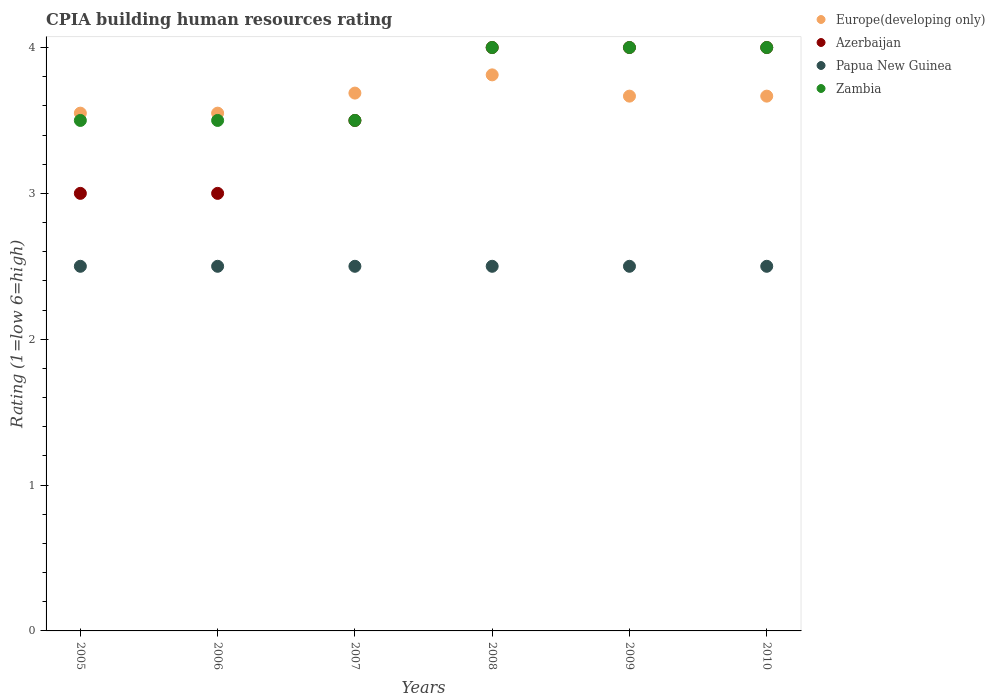How many different coloured dotlines are there?
Offer a terse response. 4. Is the number of dotlines equal to the number of legend labels?
Provide a short and direct response. Yes. What is the CPIA rating in Europe(developing only) in 2006?
Your response must be concise. 3.55. Across all years, what is the maximum CPIA rating in Europe(developing only)?
Your answer should be very brief. 3.81. Across all years, what is the minimum CPIA rating in Europe(developing only)?
Give a very brief answer. 3.55. What is the total CPIA rating in Papua New Guinea in the graph?
Your response must be concise. 15. What is the difference between the CPIA rating in Europe(developing only) in 2008 and that in 2009?
Your answer should be compact. 0.15. What is the average CPIA rating in Europe(developing only) per year?
Ensure brevity in your answer.  3.66. In the year 2009, what is the difference between the CPIA rating in Azerbaijan and CPIA rating in Europe(developing only)?
Make the answer very short. 0.33. In how many years, is the CPIA rating in Zambia greater than 3.2?
Ensure brevity in your answer.  6. What is the ratio of the CPIA rating in Europe(developing only) in 2006 to that in 2010?
Keep it short and to the point. 0.97. Is the CPIA rating in Zambia in 2007 less than that in 2010?
Provide a short and direct response. Yes. Is the difference between the CPIA rating in Azerbaijan in 2007 and 2008 greater than the difference between the CPIA rating in Europe(developing only) in 2007 and 2008?
Your answer should be compact. No. What is the difference between the highest and the second highest CPIA rating in Europe(developing only)?
Provide a succinct answer. 0.12. What is the difference between the highest and the lowest CPIA rating in Europe(developing only)?
Your answer should be very brief. 0.26. Is it the case that in every year, the sum of the CPIA rating in Zambia and CPIA rating in Europe(developing only)  is greater than the CPIA rating in Papua New Guinea?
Your answer should be compact. Yes. Is the CPIA rating in Europe(developing only) strictly less than the CPIA rating in Zambia over the years?
Your response must be concise. No. How many years are there in the graph?
Provide a short and direct response. 6. Does the graph contain any zero values?
Your answer should be very brief. No. Where does the legend appear in the graph?
Give a very brief answer. Top right. How many legend labels are there?
Provide a succinct answer. 4. How are the legend labels stacked?
Provide a short and direct response. Vertical. What is the title of the graph?
Offer a very short reply. CPIA building human resources rating. Does "Argentina" appear as one of the legend labels in the graph?
Ensure brevity in your answer.  No. What is the label or title of the X-axis?
Offer a terse response. Years. What is the Rating (1=low 6=high) in Europe(developing only) in 2005?
Your response must be concise. 3.55. What is the Rating (1=low 6=high) of Europe(developing only) in 2006?
Offer a very short reply. 3.55. What is the Rating (1=low 6=high) of Azerbaijan in 2006?
Provide a short and direct response. 3. What is the Rating (1=low 6=high) in Zambia in 2006?
Your answer should be compact. 3.5. What is the Rating (1=low 6=high) of Europe(developing only) in 2007?
Your answer should be compact. 3.69. What is the Rating (1=low 6=high) of Azerbaijan in 2007?
Offer a terse response. 3.5. What is the Rating (1=low 6=high) of Papua New Guinea in 2007?
Your answer should be compact. 2.5. What is the Rating (1=low 6=high) of Europe(developing only) in 2008?
Offer a very short reply. 3.81. What is the Rating (1=low 6=high) in Azerbaijan in 2008?
Offer a very short reply. 4. What is the Rating (1=low 6=high) of Zambia in 2008?
Offer a terse response. 4. What is the Rating (1=low 6=high) in Europe(developing only) in 2009?
Give a very brief answer. 3.67. What is the Rating (1=low 6=high) in Azerbaijan in 2009?
Make the answer very short. 4. What is the Rating (1=low 6=high) in Papua New Guinea in 2009?
Give a very brief answer. 2.5. What is the Rating (1=low 6=high) in Zambia in 2009?
Provide a short and direct response. 4. What is the Rating (1=low 6=high) of Europe(developing only) in 2010?
Your answer should be very brief. 3.67. What is the Rating (1=low 6=high) of Azerbaijan in 2010?
Make the answer very short. 4. Across all years, what is the maximum Rating (1=low 6=high) in Europe(developing only)?
Keep it short and to the point. 3.81. Across all years, what is the maximum Rating (1=low 6=high) in Azerbaijan?
Give a very brief answer. 4. Across all years, what is the maximum Rating (1=low 6=high) in Papua New Guinea?
Provide a short and direct response. 2.5. Across all years, what is the minimum Rating (1=low 6=high) of Europe(developing only)?
Offer a very short reply. 3.55. Across all years, what is the minimum Rating (1=low 6=high) in Azerbaijan?
Make the answer very short. 3. Across all years, what is the minimum Rating (1=low 6=high) in Zambia?
Your answer should be compact. 3.5. What is the total Rating (1=low 6=high) of Europe(developing only) in the graph?
Your response must be concise. 21.93. What is the total Rating (1=low 6=high) in Azerbaijan in the graph?
Provide a succinct answer. 21.5. What is the total Rating (1=low 6=high) of Papua New Guinea in the graph?
Give a very brief answer. 15. What is the difference between the Rating (1=low 6=high) in Papua New Guinea in 2005 and that in 2006?
Offer a terse response. 0. What is the difference between the Rating (1=low 6=high) in Zambia in 2005 and that in 2006?
Your response must be concise. 0. What is the difference between the Rating (1=low 6=high) of Europe(developing only) in 2005 and that in 2007?
Offer a very short reply. -0.14. What is the difference between the Rating (1=low 6=high) in Azerbaijan in 2005 and that in 2007?
Your answer should be very brief. -0.5. What is the difference between the Rating (1=low 6=high) of Papua New Guinea in 2005 and that in 2007?
Your answer should be very brief. 0. What is the difference between the Rating (1=low 6=high) in Zambia in 2005 and that in 2007?
Offer a very short reply. 0. What is the difference between the Rating (1=low 6=high) of Europe(developing only) in 2005 and that in 2008?
Your response must be concise. -0.26. What is the difference between the Rating (1=low 6=high) in Azerbaijan in 2005 and that in 2008?
Your answer should be very brief. -1. What is the difference between the Rating (1=low 6=high) of Papua New Guinea in 2005 and that in 2008?
Offer a very short reply. 0. What is the difference between the Rating (1=low 6=high) of Europe(developing only) in 2005 and that in 2009?
Make the answer very short. -0.12. What is the difference between the Rating (1=low 6=high) in Azerbaijan in 2005 and that in 2009?
Keep it short and to the point. -1. What is the difference between the Rating (1=low 6=high) of Papua New Guinea in 2005 and that in 2009?
Give a very brief answer. 0. What is the difference between the Rating (1=low 6=high) of Zambia in 2005 and that in 2009?
Your answer should be very brief. -0.5. What is the difference between the Rating (1=low 6=high) in Europe(developing only) in 2005 and that in 2010?
Provide a succinct answer. -0.12. What is the difference between the Rating (1=low 6=high) of Papua New Guinea in 2005 and that in 2010?
Offer a terse response. 0. What is the difference between the Rating (1=low 6=high) in Zambia in 2005 and that in 2010?
Your answer should be very brief. -0.5. What is the difference between the Rating (1=low 6=high) in Europe(developing only) in 2006 and that in 2007?
Your answer should be compact. -0.14. What is the difference between the Rating (1=low 6=high) in Europe(developing only) in 2006 and that in 2008?
Ensure brevity in your answer.  -0.26. What is the difference between the Rating (1=low 6=high) in Papua New Guinea in 2006 and that in 2008?
Your answer should be compact. 0. What is the difference between the Rating (1=low 6=high) of Europe(developing only) in 2006 and that in 2009?
Keep it short and to the point. -0.12. What is the difference between the Rating (1=low 6=high) of Azerbaijan in 2006 and that in 2009?
Provide a short and direct response. -1. What is the difference between the Rating (1=low 6=high) of Papua New Guinea in 2006 and that in 2009?
Your response must be concise. 0. What is the difference between the Rating (1=low 6=high) of Zambia in 2006 and that in 2009?
Your answer should be very brief. -0.5. What is the difference between the Rating (1=low 6=high) in Europe(developing only) in 2006 and that in 2010?
Make the answer very short. -0.12. What is the difference between the Rating (1=low 6=high) of Azerbaijan in 2006 and that in 2010?
Make the answer very short. -1. What is the difference between the Rating (1=low 6=high) of Papua New Guinea in 2006 and that in 2010?
Provide a succinct answer. 0. What is the difference between the Rating (1=low 6=high) in Zambia in 2006 and that in 2010?
Offer a very short reply. -0.5. What is the difference between the Rating (1=low 6=high) of Europe(developing only) in 2007 and that in 2008?
Provide a succinct answer. -0.12. What is the difference between the Rating (1=low 6=high) in Papua New Guinea in 2007 and that in 2008?
Give a very brief answer. 0. What is the difference between the Rating (1=low 6=high) in Europe(developing only) in 2007 and that in 2009?
Ensure brevity in your answer.  0.02. What is the difference between the Rating (1=low 6=high) in Papua New Guinea in 2007 and that in 2009?
Keep it short and to the point. 0. What is the difference between the Rating (1=low 6=high) of Europe(developing only) in 2007 and that in 2010?
Make the answer very short. 0.02. What is the difference between the Rating (1=low 6=high) of Azerbaijan in 2007 and that in 2010?
Your response must be concise. -0.5. What is the difference between the Rating (1=low 6=high) of Zambia in 2007 and that in 2010?
Make the answer very short. -0.5. What is the difference between the Rating (1=low 6=high) of Europe(developing only) in 2008 and that in 2009?
Offer a terse response. 0.15. What is the difference between the Rating (1=low 6=high) in Papua New Guinea in 2008 and that in 2009?
Keep it short and to the point. 0. What is the difference between the Rating (1=low 6=high) of Zambia in 2008 and that in 2009?
Offer a very short reply. 0. What is the difference between the Rating (1=low 6=high) of Europe(developing only) in 2008 and that in 2010?
Keep it short and to the point. 0.15. What is the difference between the Rating (1=low 6=high) of Zambia in 2008 and that in 2010?
Make the answer very short. 0. What is the difference between the Rating (1=low 6=high) in Europe(developing only) in 2009 and that in 2010?
Your answer should be compact. 0. What is the difference between the Rating (1=low 6=high) in Azerbaijan in 2009 and that in 2010?
Offer a terse response. 0. What is the difference between the Rating (1=low 6=high) in Europe(developing only) in 2005 and the Rating (1=low 6=high) in Azerbaijan in 2006?
Your response must be concise. 0.55. What is the difference between the Rating (1=low 6=high) in Europe(developing only) in 2005 and the Rating (1=low 6=high) in Papua New Guinea in 2006?
Provide a short and direct response. 1.05. What is the difference between the Rating (1=low 6=high) of Europe(developing only) in 2005 and the Rating (1=low 6=high) of Zambia in 2006?
Your answer should be very brief. 0.05. What is the difference between the Rating (1=low 6=high) of Azerbaijan in 2005 and the Rating (1=low 6=high) of Zambia in 2006?
Give a very brief answer. -0.5. What is the difference between the Rating (1=low 6=high) in Europe(developing only) in 2005 and the Rating (1=low 6=high) in Azerbaijan in 2007?
Offer a very short reply. 0.05. What is the difference between the Rating (1=low 6=high) in Europe(developing only) in 2005 and the Rating (1=low 6=high) in Papua New Guinea in 2007?
Your answer should be compact. 1.05. What is the difference between the Rating (1=low 6=high) in Azerbaijan in 2005 and the Rating (1=low 6=high) in Zambia in 2007?
Your answer should be compact. -0.5. What is the difference between the Rating (1=low 6=high) in Europe(developing only) in 2005 and the Rating (1=low 6=high) in Azerbaijan in 2008?
Keep it short and to the point. -0.45. What is the difference between the Rating (1=low 6=high) of Europe(developing only) in 2005 and the Rating (1=low 6=high) of Papua New Guinea in 2008?
Provide a succinct answer. 1.05. What is the difference between the Rating (1=low 6=high) of Europe(developing only) in 2005 and the Rating (1=low 6=high) of Zambia in 2008?
Give a very brief answer. -0.45. What is the difference between the Rating (1=low 6=high) of Azerbaijan in 2005 and the Rating (1=low 6=high) of Zambia in 2008?
Give a very brief answer. -1. What is the difference between the Rating (1=low 6=high) in Europe(developing only) in 2005 and the Rating (1=low 6=high) in Azerbaijan in 2009?
Offer a terse response. -0.45. What is the difference between the Rating (1=low 6=high) in Europe(developing only) in 2005 and the Rating (1=low 6=high) in Papua New Guinea in 2009?
Offer a terse response. 1.05. What is the difference between the Rating (1=low 6=high) of Europe(developing only) in 2005 and the Rating (1=low 6=high) of Zambia in 2009?
Provide a short and direct response. -0.45. What is the difference between the Rating (1=low 6=high) in Azerbaijan in 2005 and the Rating (1=low 6=high) in Zambia in 2009?
Keep it short and to the point. -1. What is the difference between the Rating (1=low 6=high) in Europe(developing only) in 2005 and the Rating (1=low 6=high) in Azerbaijan in 2010?
Offer a terse response. -0.45. What is the difference between the Rating (1=low 6=high) of Europe(developing only) in 2005 and the Rating (1=low 6=high) of Papua New Guinea in 2010?
Give a very brief answer. 1.05. What is the difference between the Rating (1=low 6=high) in Europe(developing only) in 2005 and the Rating (1=low 6=high) in Zambia in 2010?
Your answer should be very brief. -0.45. What is the difference between the Rating (1=low 6=high) in Azerbaijan in 2005 and the Rating (1=low 6=high) in Papua New Guinea in 2010?
Ensure brevity in your answer.  0.5. What is the difference between the Rating (1=low 6=high) in Azerbaijan in 2005 and the Rating (1=low 6=high) in Zambia in 2010?
Offer a very short reply. -1. What is the difference between the Rating (1=low 6=high) of Europe(developing only) in 2006 and the Rating (1=low 6=high) of Papua New Guinea in 2007?
Your answer should be very brief. 1.05. What is the difference between the Rating (1=low 6=high) in Europe(developing only) in 2006 and the Rating (1=low 6=high) in Zambia in 2007?
Offer a very short reply. 0.05. What is the difference between the Rating (1=low 6=high) in Azerbaijan in 2006 and the Rating (1=low 6=high) in Zambia in 2007?
Offer a terse response. -0.5. What is the difference between the Rating (1=low 6=high) in Papua New Guinea in 2006 and the Rating (1=low 6=high) in Zambia in 2007?
Keep it short and to the point. -1. What is the difference between the Rating (1=low 6=high) in Europe(developing only) in 2006 and the Rating (1=low 6=high) in Azerbaijan in 2008?
Your answer should be compact. -0.45. What is the difference between the Rating (1=low 6=high) in Europe(developing only) in 2006 and the Rating (1=low 6=high) in Papua New Guinea in 2008?
Your answer should be very brief. 1.05. What is the difference between the Rating (1=low 6=high) of Europe(developing only) in 2006 and the Rating (1=low 6=high) of Zambia in 2008?
Make the answer very short. -0.45. What is the difference between the Rating (1=low 6=high) in Azerbaijan in 2006 and the Rating (1=low 6=high) in Papua New Guinea in 2008?
Your response must be concise. 0.5. What is the difference between the Rating (1=low 6=high) in Azerbaijan in 2006 and the Rating (1=low 6=high) in Zambia in 2008?
Your response must be concise. -1. What is the difference between the Rating (1=low 6=high) of Europe(developing only) in 2006 and the Rating (1=low 6=high) of Azerbaijan in 2009?
Offer a very short reply. -0.45. What is the difference between the Rating (1=low 6=high) in Europe(developing only) in 2006 and the Rating (1=low 6=high) in Zambia in 2009?
Your response must be concise. -0.45. What is the difference between the Rating (1=low 6=high) of Azerbaijan in 2006 and the Rating (1=low 6=high) of Papua New Guinea in 2009?
Your answer should be compact. 0.5. What is the difference between the Rating (1=low 6=high) of Azerbaijan in 2006 and the Rating (1=low 6=high) of Zambia in 2009?
Your response must be concise. -1. What is the difference between the Rating (1=low 6=high) in Papua New Guinea in 2006 and the Rating (1=low 6=high) in Zambia in 2009?
Your answer should be very brief. -1.5. What is the difference between the Rating (1=low 6=high) in Europe(developing only) in 2006 and the Rating (1=low 6=high) in Azerbaijan in 2010?
Keep it short and to the point. -0.45. What is the difference between the Rating (1=low 6=high) in Europe(developing only) in 2006 and the Rating (1=low 6=high) in Zambia in 2010?
Your answer should be compact. -0.45. What is the difference between the Rating (1=low 6=high) of Azerbaijan in 2006 and the Rating (1=low 6=high) of Papua New Guinea in 2010?
Provide a succinct answer. 0.5. What is the difference between the Rating (1=low 6=high) of Azerbaijan in 2006 and the Rating (1=low 6=high) of Zambia in 2010?
Your answer should be compact. -1. What is the difference between the Rating (1=low 6=high) in Papua New Guinea in 2006 and the Rating (1=low 6=high) in Zambia in 2010?
Provide a short and direct response. -1.5. What is the difference between the Rating (1=low 6=high) of Europe(developing only) in 2007 and the Rating (1=low 6=high) of Azerbaijan in 2008?
Provide a succinct answer. -0.31. What is the difference between the Rating (1=low 6=high) of Europe(developing only) in 2007 and the Rating (1=low 6=high) of Papua New Guinea in 2008?
Give a very brief answer. 1.19. What is the difference between the Rating (1=low 6=high) of Europe(developing only) in 2007 and the Rating (1=low 6=high) of Zambia in 2008?
Ensure brevity in your answer.  -0.31. What is the difference between the Rating (1=low 6=high) in Azerbaijan in 2007 and the Rating (1=low 6=high) in Zambia in 2008?
Make the answer very short. -0.5. What is the difference between the Rating (1=low 6=high) of Europe(developing only) in 2007 and the Rating (1=low 6=high) of Azerbaijan in 2009?
Provide a succinct answer. -0.31. What is the difference between the Rating (1=low 6=high) of Europe(developing only) in 2007 and the Rating (1=low 6=high) of Papua New Guinea in 2009?
Your answer should be very brief. 1.19. What is the difference between the Rating (1=low 6=high) of Europe(developing only) in 2007 and the Rating (1=low 6=high) of Zambia in 2009?
Make the answer very short. -0.31. What is the difference between the Rating (1=low 6=high) of Azerbaijan in 2007 and the Rating (1=low 6=high) of Papua New Guinea in 2009?
Give a very brief answer. 1. What is the difference between the Rating (1=low 6=high) of Papua New Guinea in 2007 and the Rating (1=low 6=high) of Zambia in 2009?
Provide a succinct answer. -1.5. What is the difference between the Rating (1=low 6=high) in Europe(developing only) in 2007 and the Rating (1=low 6=high) in Azerbaijan in 2010?
Offer a very short reply. -0.31. What is the difference between the Rating (1=low 6=high) in Europe(developing only) in 2007 and the Rating (1=low 6=high) in Papua New Guinea in 2010?
Your response must be concise. 1.19. What is the difference between the Rating (1=low 6=high) of Europe(developing only) in 2007 and the Rating (1=low 6=high) of Zambia in 2010?
Your answer should be compact. -0.31. What is the difference between the Rating (1=low 6=high) of Azerbaijan in 2007 and the Rating (1=low 6=high) of Papua New Guinea in 2010?
Provide a succinct answer. 1. What is the difference between the Rating (1=low 6=high) in Azerbaijan in 2007 and the Rating (1=low 6=high) in Zambia in 2010?
Make the answer very short. -0.5. What is the difference between the Rating (1=low 6=high) of Europe(developing only) in 2008 and the Rating (1=low 6=high) of Azerbaijan in 2009?
Your response must be concise. -0.19. What is the difference between the Rating (1=low 6=high) in Europe(developing only) in 2008 and the Rating (1=low 6=high) in Papua New Guinea in 2009?
Your response must be concise. 1.31. What is the difference between the Rating (1=low 6=high) of Europe(developing only) in 2008 and the Rating (1=low 6=high) of Zambia in 2009?
Your answer should be compact. -0.19. What is the difference between the Rating (1=low 6=high) in Azerbaijan in 2008 and the Rating (1=low 6=high) in Papua New Guinea in 2009?
Provide a short and direct response. 1.5. What is the difference between the Rating (1=low 6=high) in Azerbaijan in 2008 and the Rating (1=low 6=high) in Zambia in 2009?
Your answer should be very brief. 0. What is the difference between the Rating (1=low 6=high) of Papua New Guinea in 2008 and the Rating (1=low 6=high) of Zambia in 2009?
Your answer should be very brief. -1.5. What is the difference between the Rating (1=low 6=high) of Europe(developing only) in 2008 and the Rating (1=low 6=high) of Azerbaijan in 2010?
Give a very brief answer. -0.19. What is the difference between the Rating (1=low 6=high) of Europe(developing only) in 2008 and the Rating (1=low 6=high) of Papua New Guinea in 2010?
Make the answer very short. 1.31. What is the difference between the Rating (1=low 6=high) of Europe(developing only) in 2008 and the Rating (1=low 6=high) of Zambia in 2010?
Your answer should be very brief. -0.19. What is the difference between the Rating (1=low 6=high) of Azerbaijan in 2008 and the Rating (1=low 6=high) of Zambia in 2010?
Keep it short and to the point. 0. What is the difference between the Rating (1=low 6=high) of Europe(developing only) in 2009 and the Rating (1=low 6=high) of Azerbaijan in 2010?
Ensure brevity in your answer.  -0.33. What is the difference between the Rating (1=low 6=high) of Europe(developing only) in 2009 and the Rating (1=low 6=high) of Papua New Guinea in 2010?
Provide a short and direct response. 1.17. What is the difference between the Rating (1=low 6=high) of Azerbaijan in 2009 and the Rating (1=low 6=high) of Papua New Guinea in 2010?
Provide a succinct answer. 1.5. What is the difference between the Rating (1=low 6=high) of Papua New Guinea in 2009 and the Rating (1=low 6=high) of Zambia in 2010?
Make the answer very short. -1.5. What is the average Rating (1=low 6=high) of Europe(developing only) per year?
Provide a succinct answer. 3.66. What is the average Rating (1=low 6=high) of Azerbaijan per year?
Give a very brief answer. 3.58. What is the average Rating (1=low 6=high) in Zambia per year?
Provide a short and direct response. 3.75. In the year 2005, what is the difference between the Rating (1=low 6=high) in Europe(developing only) and Rating (1=low 6=high) in Azerbaijan?
Your answer should be compact. 0.55. In the year 2005, what is the difference between the Rating (1=low 6=high) of Europe(developing only) and Rating (1=low 6=high) of Zambia?
Your response must be concise. 0.05. In the year 2005, what is the difference between the Rating (1=low 6=high) of Azerbaijan and Rating (1=low 6=high) of Papua New Guinea?
Your response must be concise. 0.5. In the year 2005, what is the difference between the Rating (1=low 6=high) in Azerbaijan and Rating (1=low 6=high) in Zambia?
Make the answer very short. -0.5. In the year 2006, what is the difference between the Rating (1=low 6=high) of Europe(developing only) and Rating (1=low 6=high) of Azerbaijan?
Offer a very short reply. 0.55. In the year 2006, what is the difference between the Rating (1=low 6=high) of Azerbaijan and Rating (1=low 6=high) of Papua New Guinea?
Make the answer very short. 0.5. In the year 2007, what is the difference between the Rating (1=low 6=high) in Europe(developing only) and Rating (1=low 6=high) in Azerbaijan?
Give a very brief answer. 0.19. In the year 2007, what is the difference between the Rating (1=low 6=high) of Europe(developing only) and Rating (1=low 6=high) of Papua New Guinea?
Keep it short and to the point. 1.19. In the year 2007, what is the difference between the Rating (1=low 6=high) in Europe(developing only) and Rating (1=low 6=high) in Zambia?
Your response must be concise. 0.19. In the year 2007, what is the difference between the Rating (1=low 6=high) in Azerbaijan and Rating (1=low 6=high) in Zambia?
Provide a short and direct response. 0. In the year 2008, what is the difference between the Rating (1=low 6=high) in Europe(developing only) and Rating (1=low 6=high) in Azerbaijan?
Make the answer very short. -0.19. In the year 2008, what is the difference between the Rating (1=low 6=high) in Europe(developing only) and Rating (1=low 6=high) in Papua New Guinea?
Your response must be concise. 1.31. In the year 2008, what is the difference between the Rating (1=low 6=high) in Europe(developing only) and Rating (1=low 6=high) in Zambia?
Keep it short and to the point. -0.19. In the year 2008, what is the difference between the Rating (1=low 6=high) of Azerbaijan and Rating (1=low 6=high) of Papua New Guinea?
Keep it short and to the point. 1.5. In the year 2009, what is the difference between the Rating (1=low 6=high) in Azerbaijan and Rating (1=low 6=high) in Zambia?
Ensure brevity in your answer.  0. In the year 2010, what is the difference between the Rating (1=low 6=high) in Europe(developing only) and Rating (1=low 6=high) in Azerbaijan?
Offer a very short reply. -0.33. In the year 2010, what is the difference between the Rating (1=low 6=high) in Europe(developing only) and Rating (1=low 6=high) in Papua New Guinea?
Offer a very short reply. 1.17. In the year 2010, what is the difference between the Rating (1=low 6=high) in Azerbaijan and Rating (1=low 6=high) in Papua New Guinea?
Provide a short and direct response. 1.5. In the year 2010, what is the difference between the Rating (1=low 6=high) in Azerbaijan and Rating (1=low 6=high) in Zambia?
Make the answer very short. 0. What is the ratio of the Rating (1=low 6=high) of Europe(developing only) in 2005 to that in 2006?
Provide a succinct answer. 1. What is the ratio of the Rating (1=low 6=high) in Zambia in 2005 to that in 2006?
Give a very brief answer. 1. What is the ratio of the Rating (1=low 6=high) of Europe(developing only) in 2005 to that in 2007?
Give a very brief answer. 0.96. What is the ratio of the Rating (1=low 6=high) in Papua New Guinea in 2005 to that in 2007?
Your response must be concise. 1. What is the ratio of the Rating (1=low 6=high) in Europe(developing only) in 2005 to that in 2008?
Provide a succinct answer. 0.93. What is the ratio of the Rating (1=low 6=high) of Azerbaijan in 2005 to that in 2008?
Your response must be concise. 0.75. What is the ratio of the Rating (1=low 6=high) of Zambia in 2005 to that in 2008?
Offer a terse response. 0.88. What is the ratio of the Rating (1=low 6=high) of Europe(developing only) in 2005 to that in 2009?
Your response must be concise. 0.97. What is the ratio of the Rating (1=low 6=high) in Azerbaijan in 2005 to that in 2009?
Keep it short and to the point. 0.75. What is the ratio of the Rating (1=low 6=high) of Zambia in 2005 to that in 2009?
Provide a short and direct response. 0.88. What is the ratio of the Rating (1=low 6=high) in Europe(developing only) in 2005 to that in 2010?
Offer a very short reply. 0.97. What is the ratio of the Rating (1=low 6=high) in Azerbaijan in 2005 to that in 2010?
Provide a short and direct response. 0.75. What is the ratio of the Rating (1=low 6=high) in Papua New Guinea in 2005 to that in 2010?
Offer a very short reply. 1. What is the ratio of the Rating (1=low 6=high) of Europe(developing only) in 2006 to that in 2007?
Provide a succinct answer. 0.96. What is the ratio of the Rating (1=low 6=high) in Azerbaijan in 2006 to that in 2007?
Provide a short and direct response. 0.86. What is the ratio of the Rating (1=low 6=high) in Europe(developing only) in 2006 to that in 2008?
Keep it short and to the point. 0.93. What is the ratio of the Rating (1=low 6=high) in Azerbaijan in 2006 to that in 2008?
Provide a short and direct response. 0.75. What is the ratio of the Rating (1=low 6=high) in Zambia in 2006 to that in 2008?
Your response must be concise. 0.88. What is the ratio of the Rating (1=low 6=high) in Europe(developing only) in 2006 to that in 2009?
Your response must be concise. 0.97. What is the ratio of the Rating (1=low 6=high) in Zambia in 2006 to that in 2009?
Provide a succinct answer. 0.88. What is the ratio of the Rating (1=low 6=high) in Europe(developing only) in 2006 to that in 2010?
Make the answer very short. 0.97. What is the ratio of the Rating (1=low 6=high) in Azerbaijan in 2006 to that in 2010?
Keep it short and to the point. 0.75. What is the ratio of the Rating (1=low 6=high) of Europe(developing only) in 2007 to that in 2008?
Offer a very short reply. 0.97. What is the ratio of the Rating (1=low 6=high) in Azerbaijan in 2007 to that in 2008?
Ensure brevity in your answer.  0.88. What is the ratio of the Rating (1=low 6=high) in Papua New Guinea in 2007 to that in 2008?
Your answer should be very brief. 1. What is the ratio of the Rating (1=low 6=high) in Zambia in 2007 to that in 2008?
Make the answer very short. 0.88. What is the ratio of the Rating (1=low 6=high) in Europe(developing only) in 2007 to that in 2009?
Ensure brevity in your answer.  1.01. What is the ratio of the Rating (1=low 6=high) of Papua New Guinea in 2007 to that in 2009?
Provide a short and direct response. 1. What is the ratio of the Rating (1=low 6=high) in Zambia in 2007 to that in 2009?
Your answer should be compact. 0.88. What is the ratio of the Rating (1=low 6=high) of Europe(developing only) in 2007 to that in 2010?
Offer a very short reply. 1.01. What is the ratio of the Rating (1=low 6=high) in Azerbaijan in 2007 to that in 2010?
Offer a very short reply. 0.88. What is the ratio of the Rating (1=low 6=high) of Papua New Guinea in 2007 to that in 2010?
Give a very brief answer. 1. What is the ratio of the Rating (1=low 6=high) in Zambia in 2007 to that in 2010?
Your answer should be compact. 0.88. What is the ratio of the Rating (1=low 6=high) of Europe(developing only) in 2008 to that in 2009?
Your response must be concise. 1.04. What is the ratio of the Rating (1=low 6=high) in Azerbaijan in 2008 to that in 2009?
Keep it short and to the point. 1. What is the ratio of the Rating (1=low 6=high) of Papua New Guinea in 2008 to that in 2009?
Provide a short and direct response. 1. What is the ratio of the Rating (1=low 6=high) of Europe(developing only) in 2008 to that in 2010?
Your answer should be compact. 1.04. What is the ratio of the Rating (1=low 6=high) of Papua New Guinea in 2009 to that in 2010?
Offer a terse response. 1. What is the ratio of the Rating (1=low 6=high) in Zambia in 2009 to that in 2010?
Your answer should be very brief. 1. What is the difference between the highest and the second highest Rating (1=low 6=high) in Azerbaijan?
Ensure brevity in your answer.  0. What is the difference between the highest and the second highest Rating (1=low 6=high) in Papua New Guinea?
Your answer should be very brief. 0. What is the difference between the highest and the lowest Rating (1=low 6=high) of Europe(developing only)?
Keep it short and to the point. 0.26. What is the difference between the highest and the lowest Rating (1=low 6=high) of Papua New Guinea?
Your answer should be compact. 0. What is the difference between the highest and the lowest Rating (1=low 6=high) in Zambia?
Your answer should be very brief. 0.5. 